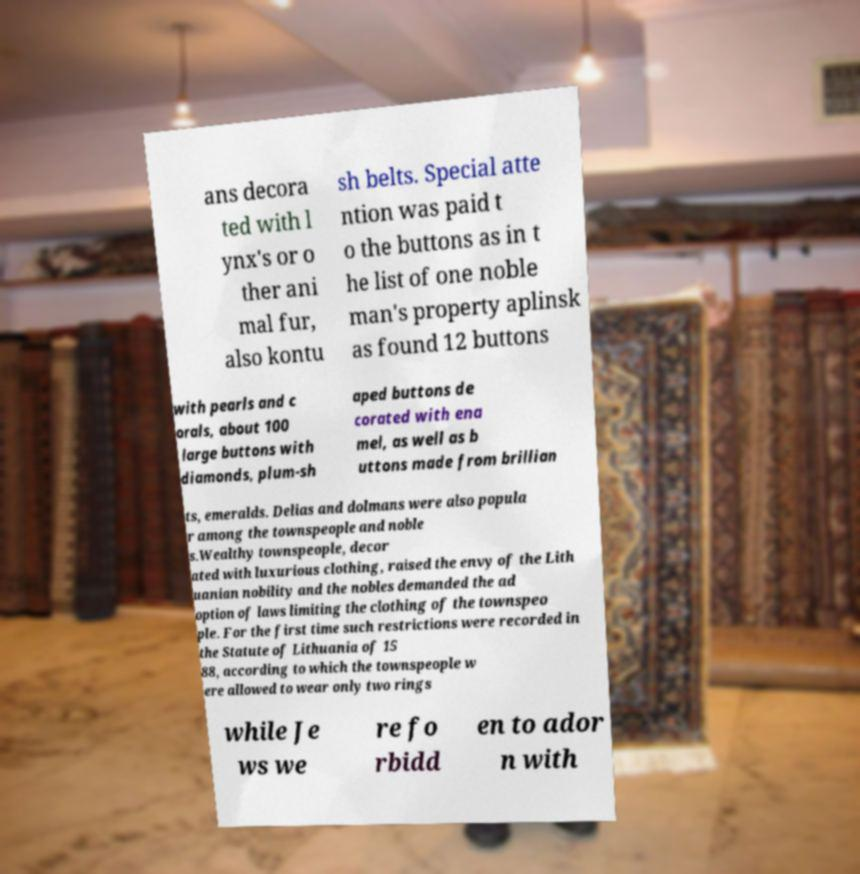Could you extract and type out the text from this image? ans decora ted with l ynx's or o ther ani mal fur, also kontu sh belts. Special atte ntion was paid t o the buttons as in t he list of one noble man's property aplinsk as found 12 buttons with pearls and c orals, about 100 large buttons with diamonds, plum-sh aped buttons de corated with ena mel, as well as b uttons made from brillian ts, emeralds. Delias and dolmans were also popula r among the townspeople and noble s.Wealthy townspeople, decor ated with luxurious clothing, raised the envy of the Lith uanian nobility and the nobles demanded the ad option of laws limiting the clothing of the townspeo ple. For the first time such restrictions were recorded in the Statute of Lithuania of 15 88, according to which the townspeople w ere allowed to wear only two rings while Je ws we re fo rbidd en to ador n with 